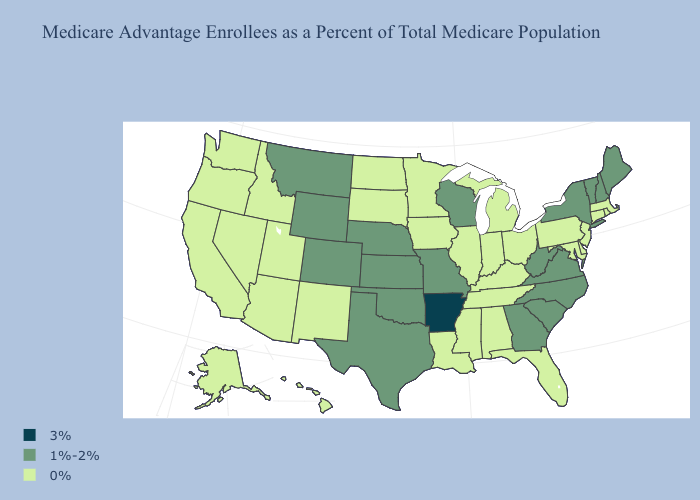Among the states that border Tennessee , does Arkansas have the highest value?
Be succinct. Yes. Does Oklahoma have the lowest value in the South?
Concise answer only. No. How many symbols are there in the legend?
Short answer required. 3. Among the states that border Kansas , which have the lowest value?
Be succinct. Colorado, Missouri, Nebraska, Oklahoma. Which states have the lowest value in the USA?
Concise answer only. Alaska, Alabama, Arizona, California, Connecticut, Delaware, Florida, Hawaii, Iowa, Idaho, Illinois, Indiana, Kentucky, Louisiana, Massachusetts, Maryland, Michigan, Minnesota, Mississippi, North Dakota, New Jersey, New Mexico, Nevada, Ohio, Oregon, Pennsylvania, Rhode Island, South Dakota, Tennessee, Utah, Washington. What is the highest value in the USA?
Give a very brief answer. 3%. What is the highest value in the Northeast ?
Quick response, please. 1%-2%. Name the states that have a value in the range 3%?
Concise answer only. Arkansas. Does Indiana have a lower value than Vermont?
Short answer required. Yes. Among the states that border Vermont , does Massachusetts have the highest value?
Concise answer only. No. Does the first symbol in the legend represent the smallest category?
Give a very brief answer. No. What is the highest value in the USA?
Be succinct. 3%. Name the states that have a value in the range 0%?
Short answer required. Alaska, Alabama, Arizona, California, Connecticut, Delaware, Florida, Hawaii, Iowa, Idaho, Illinois, Indiana, Kentucky, Louisiana, Massachusetts, Maryland, Michigan, Minnesota, Mississippi, North Dakota, New Jersey, New Mexico, Nevada, Ohio, Oregon, Pennsylvania, Rhode Island, South Dakota, Tennessee, Utah, Washington. What is the value of Missouri?
Quick response, please. 1%-2%. What is the highest value in states that border California?
Short answer required. 0%. 